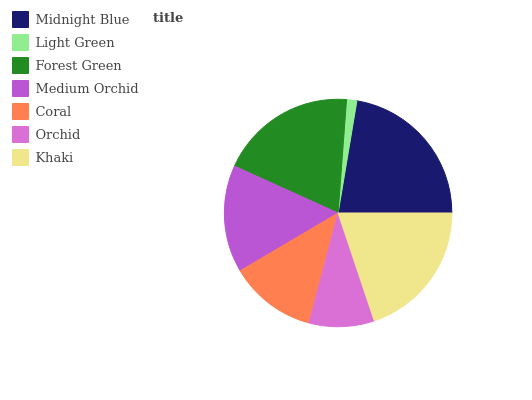Is Light Green the minimum?
Answer yes or no. Yes. Is Midnight Blue the maximum?
Answer yes or no. Yes. Is Forest Green the minimum?
Answer yes or no. No. Is Forest Green the maximum?
Answer yes or no. No. Is Forest Green greater than Light Green?
Answer yes or no. Yes. Is Light Green less than Forest Green?
Answer yes or no. Yes. Is Light Green greater than Forest Green?
Answer yes or no. No. Is Forest Green less than Light Green?
Answer yes or no. No. Is Medium Orchid the high median?
Answer yes or no. Yes. Is Medium Orchid the low median?
Answer yes or no. Yes. Is Forest Green the high median?
Answer yes or no. No. Is Midnight Blue the low median?
Answer yes or no. No. 